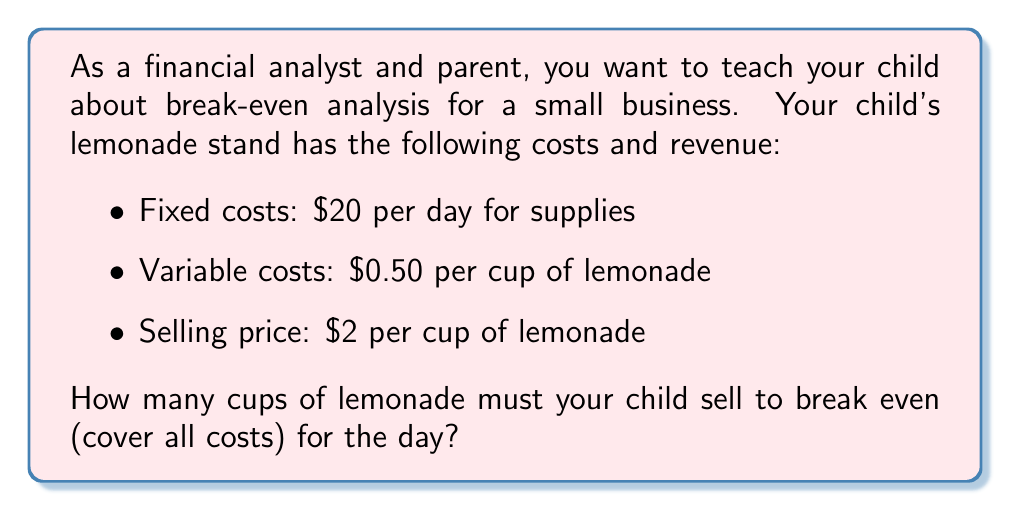Give your solution to this math problem. Let's break this down step-by-step:

1. Define the variables:
   Let $x$ = number of cups sold

2. Calculate the revenue function:
   Revenue = Price per cup × Number of cups sold
   $R(x) = 2x$

3. Calculate the total cost function:
   Total Cost = Fixed costs + (Variable cost per cup × Number of cups sold)
   $C(x) = 20 + 0.50x$

4. At the break-even point, revenue equals total cost:
   $R(x) = C(x)$
   $2x = 20 + 0.50x$

5. Solve the equation:
   $2x - 0.50x = 20$
   $1.50x = 20$
   $x = \frac{20}{1.50} = 13.33$

6. Since we can't sell a fraction of a cup, we round up to the nearest whole number.

Thus, your child needs to sell 14 cups of lemonade to break even.

To verify:
Revenue: $2 × 14 = $28
Total Cost: $20 + ($0.50 × 14) = $27
Profit: $28 - $27 = $1

This shows that selling 14 cups covers all costs and starts to generate a small profit.
Answer: 14 cups of lemonade 